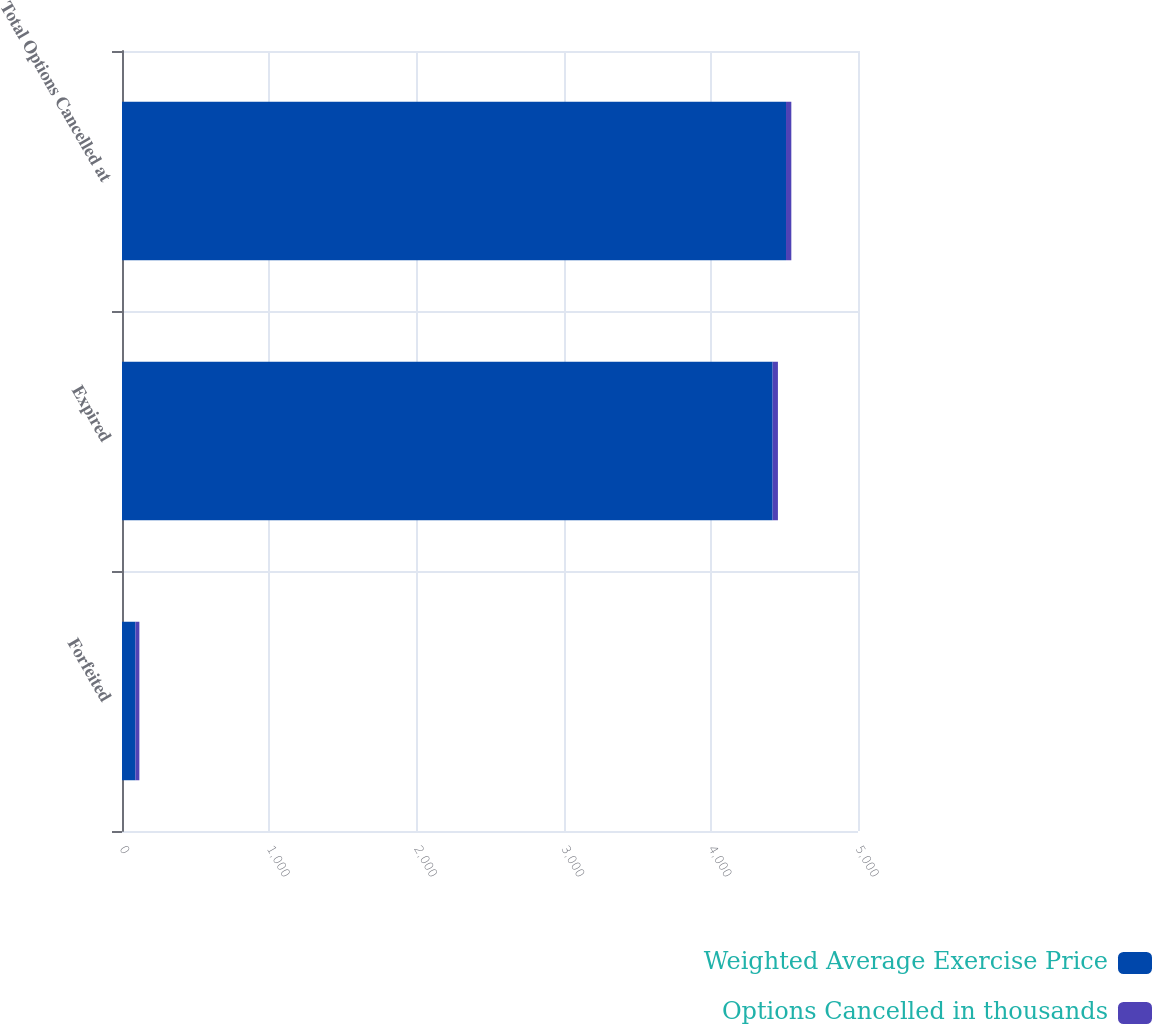Convert chart. <chart><loc_0><loc_0><loc_500><loc_500><stacked_bar_chart><ecel><fcel>Forfeited<fcel>Expired<fcel>Total Options Cancelled at<nl><fcel>Weighted Average Exercise Price<fcel>91<fcel>4420<fcel>4511<nl><fcel>Options Cancelled in thousands<fcel>27<fcel>36<fcel>36<nl></chart> 